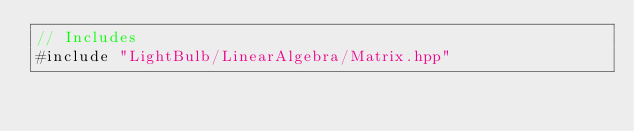<code> <loc_0><loc_0><loc_500><loc_500><_C++_>// Includes
#include "LightBulb/LinearAlgebra/Matrix.hpp"
</code> 